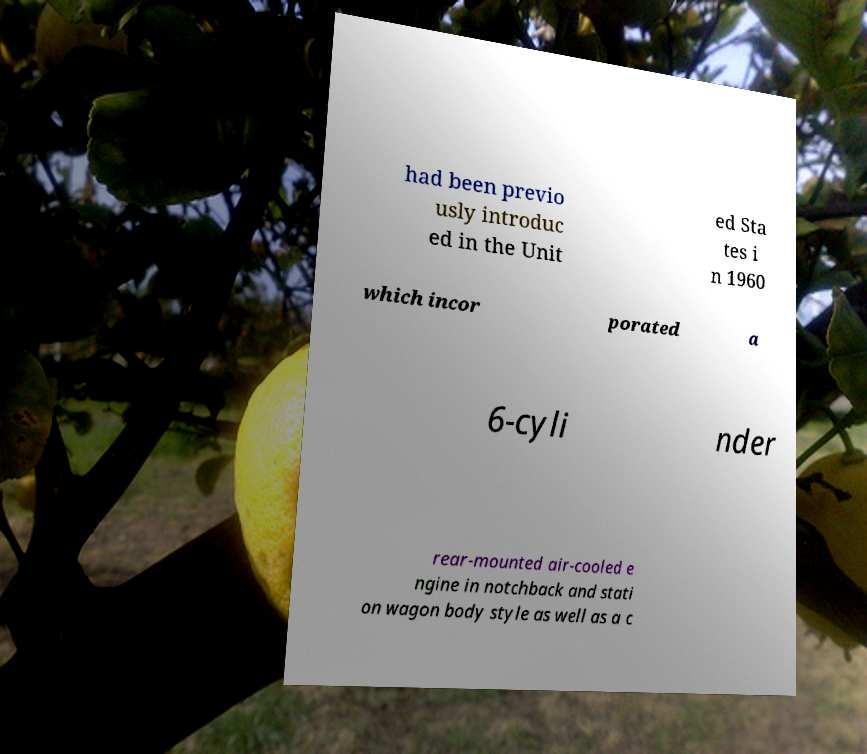Could you assist in decoding the text presented in this image and type it out clearly? had been previo usly introduc ed in the Unit ed Sta tes i n 1960 which incor porated a 6-cyli nder rear-mounted air-cooled e ngine in notchback and stati on wagon body style as well as a c 